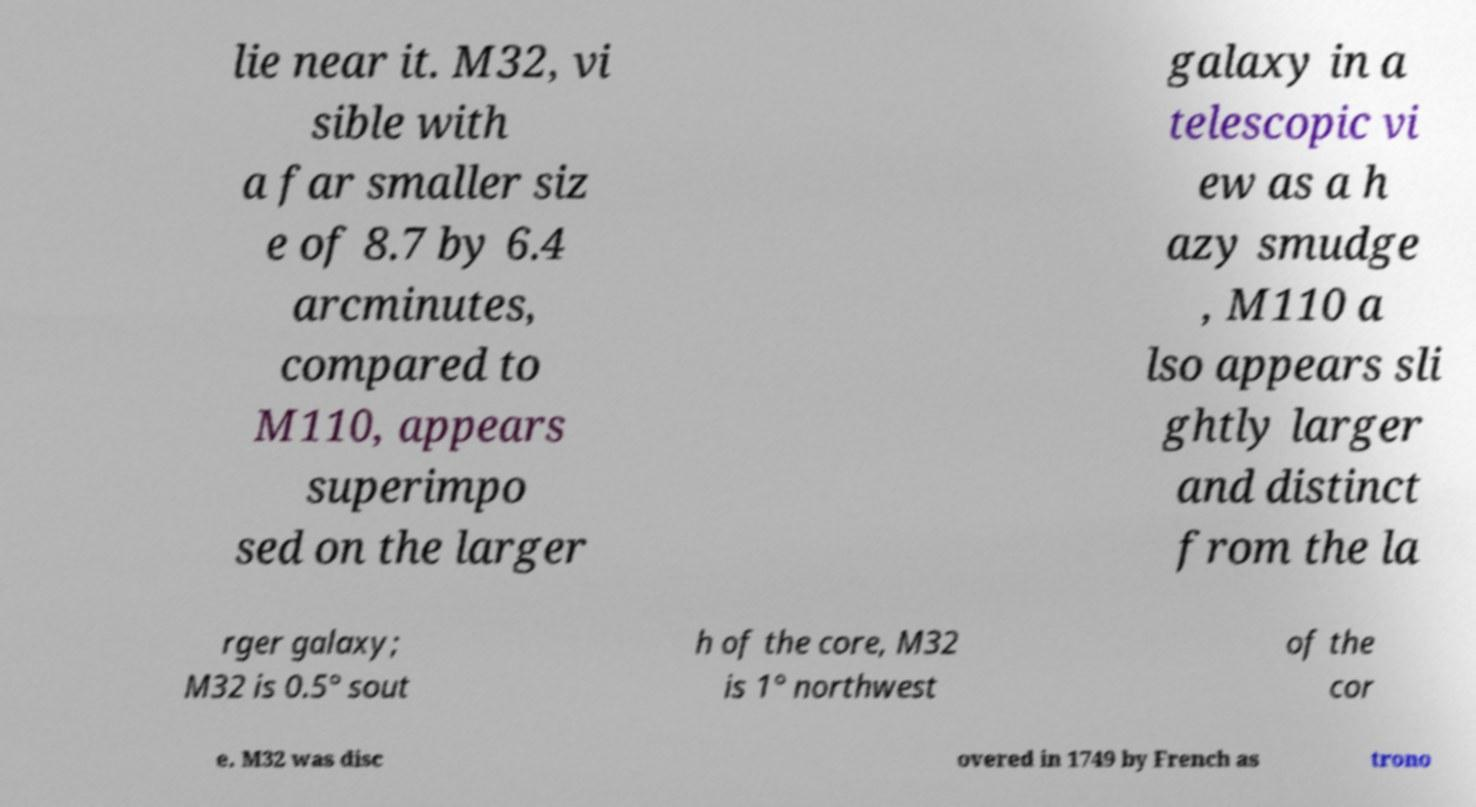Can you accurately transcribe the text from the provided image for me? lie near it. M32, vi sible with a far smaller siz e of 8.7 by 6.4 arcminutes, compared to M110, appears superimpo sed on the larger galaxy in a telescopic vi ew as a h azy smudge , M110 a lso appears sli ghtly larger and distinct from the la rger galaxy; M32 is 0.5° sout h of the core, M32 is 1° northwest of the cor e. M32 was disc overed in 1749 by French as trono 